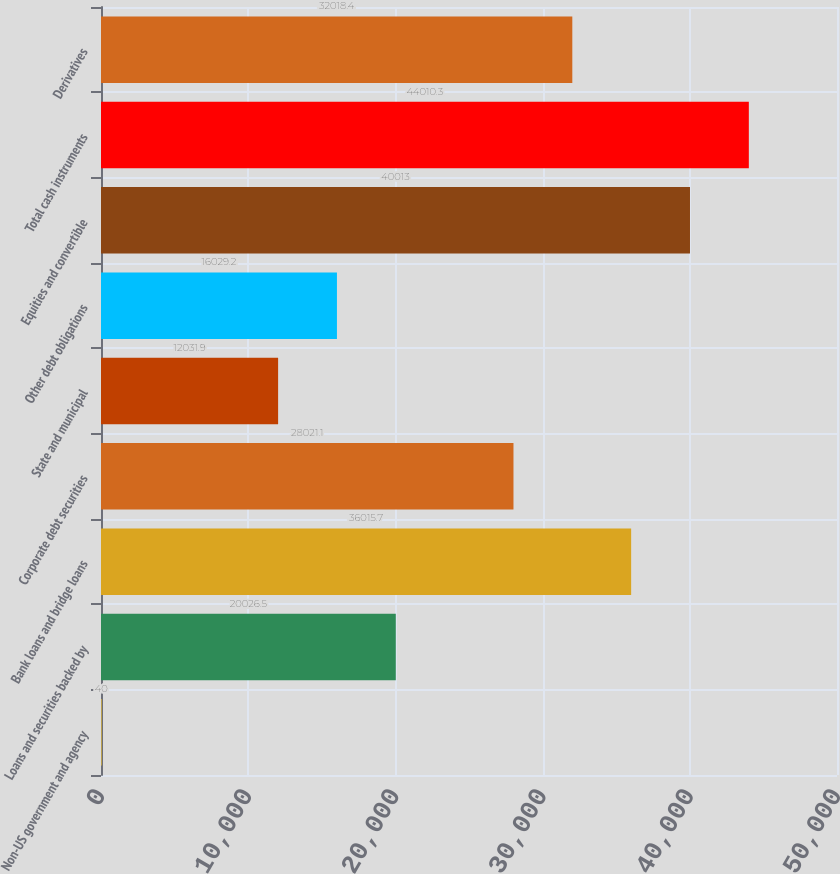Convert chart to OTSL. <chart><loc_0><loc_0><loc_500><loc_500><bar_chart><fcel>Non-US government and agency<fcel>Loans and securities backed by<fcel>Bank loans and bridge loans<fcel>Corporate debt securities<fcel>State and municipal<fcel>Other debt obligations<fcel>Equities and convertible<fcel>Total cash instruments<fcel>Derivatives<nl><fcel>40<fcel>20026.5<fcel>36015.7<fcel>28021.1<fcel>12031.9<fcel>16029.2<fcel>40013<fcel>44010.3<fcel>32018.4<nl></chart> 